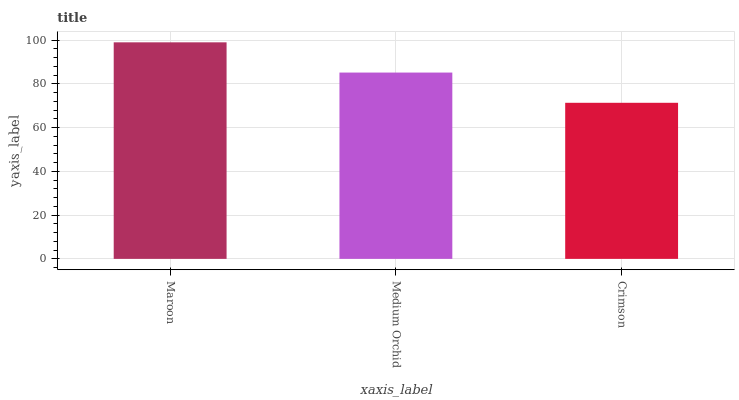Is Medium Orchid the minimum?
Answer yes or no. No. Is Medium Orchid the maximum?
Answer yes or no. No. Is Maroon greater than Medium Orchid?
Answer yes or no. Yes. Is Medium Orchid less than Maroon?
Answer yes or no. Yes. Is Medium Orchid greater than Maroon?
Answer yes or no. No. Is Maroon less than Medium Orchid?
Answer yes or no. No. Is Medium Orchid the high median?
Answer yes or no. Yes. Is Medium Orchid the low median?
Answer yes or no. Yes. Is Crimson the high median?
Answer yes or no. No. Is Maroon the low median?
Answer yes or no. No. 